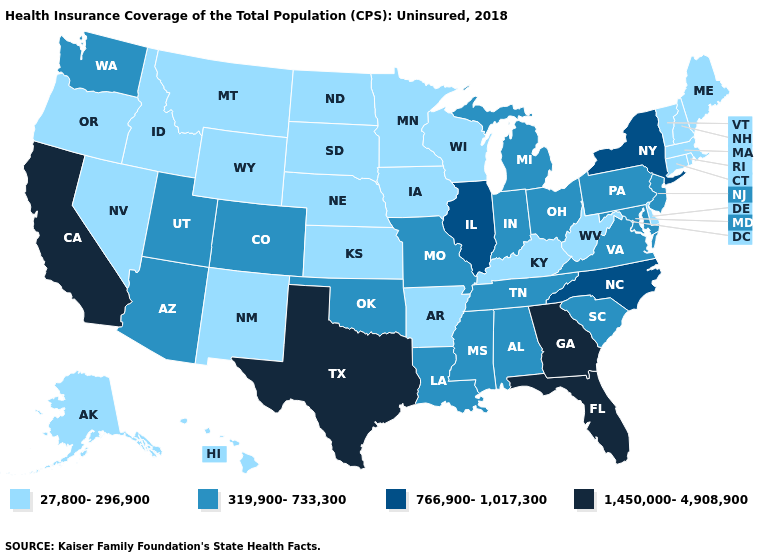Which states have the highest value in the USA?
Answer briefly. California, Florida, Georgia, Texas. Name the states that have a value in the range 1,450,000-4,908,900?
Keep it brief. California, Florida, Georgia, Texas. What is the value of Mississippi?
Short answer required. 319,900-733,300. What is the value of Wyoming?
Keep it brief. 27,800-296,900. What is the highest value in the USA?
Answer briefly. 1,450,000-4,908,900. What is the lowest value in the USA?
Give a very brief answer. 27,800-296,900. What is the value of Connecticut?
Concise answer only. 27,800-296,900. Name the states that have a value in the range 1,450,000-4,908,900?
Keep it brief. California, Florida, Georgia, Texas. Name the states that have a value in the range 766,900-1,017,300?
Keep it brief. Illinois, New York, North Carolina. What is the value of Connecticut?
Keep it brief. 27,800-296,900. What is the value of Louisiana?
Write a very short answer. 319,900-733,300. What is the value of California?
Short answer required. 1,450,000-4,908,900. Does Hawaii have the lowest value in the West?
Keep it brief. Yes. How many symbols are there in the legend?
Short answer required. 4. 